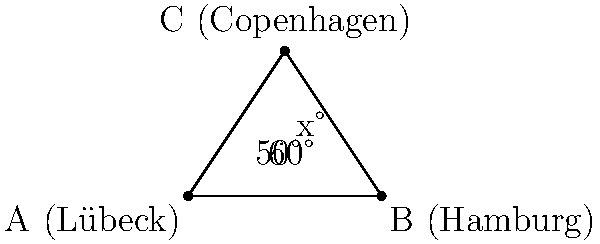In the Northern European trade network, three major cities form a triangle: Lübeck (A), Hamburg (B), and Copenhagen (C). The angle between the trade routes Lübeck-Hamburg and Lübeck-Copenhagen is 60°, while the angle between Hamburg-Copenhagen and Hamburg-Lübeck is 50°. What is the measure of angle $x$ at Copenhagen, formed by the trade routes Copenhagen-Lübeck and Copenhagen-Hamburg? To solve this problem, we'll use the fact that the sum of angles in a triangle is always 180°.

1) Let's define our angles:
   - Angle at A (Lübeck) = 60°
   - Angle at B (Hamburg) = 50°
   - Angle at C (Copenhagen) = $x°$

2) We know that the sum of these angles must equal 180°:
   
   $60° + 50° + x° = 180°$

3) Simplify the left side of the equation:
   
   $110° + x° = 180°$

4) Subtract 110° from both sides:
   
   $x° = 180° - 110°$

5) Simplify:
   
   $x° = 70°$

Therefore, the angle $x$ at Copenhagen is 70°.
Answer: 70° 